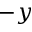Convert formula to latex. <formula><loc_0><loc_0><loc_500><loc_500>- y</formula> 